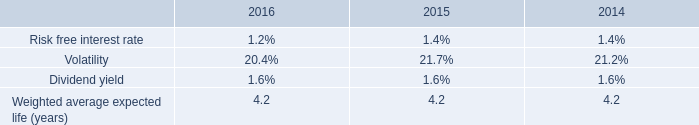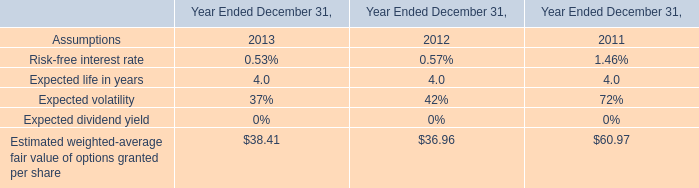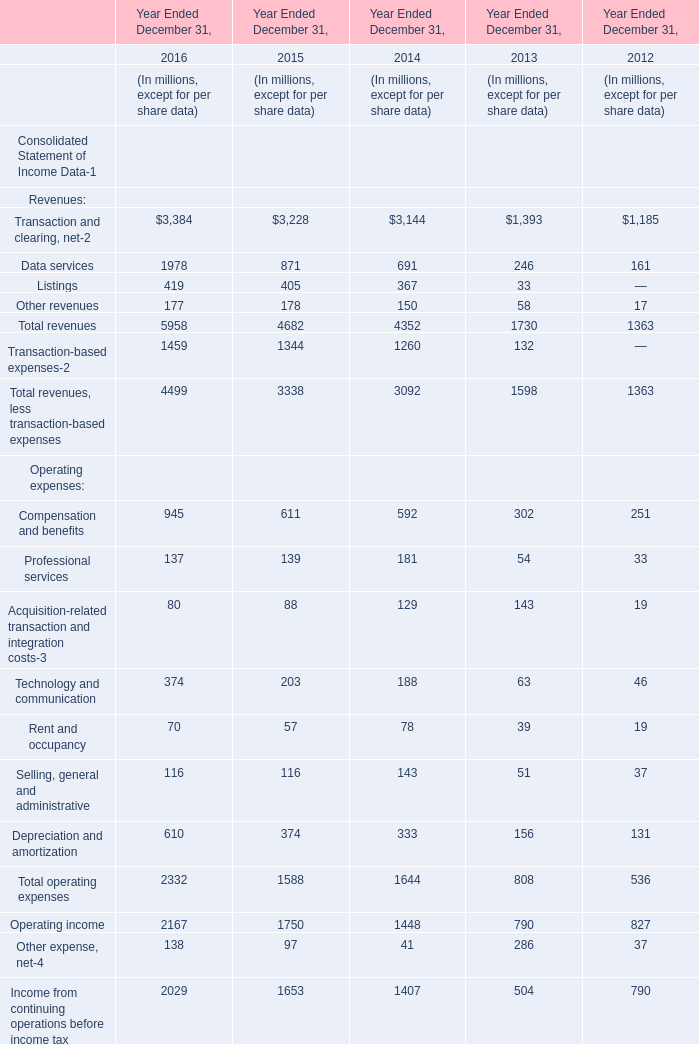what is the percentage increase in the fair value of of options from 2015 to 2016? 
Computations: ((9.35 - 10.67) / 10.67)
Answer: -0.12371. 